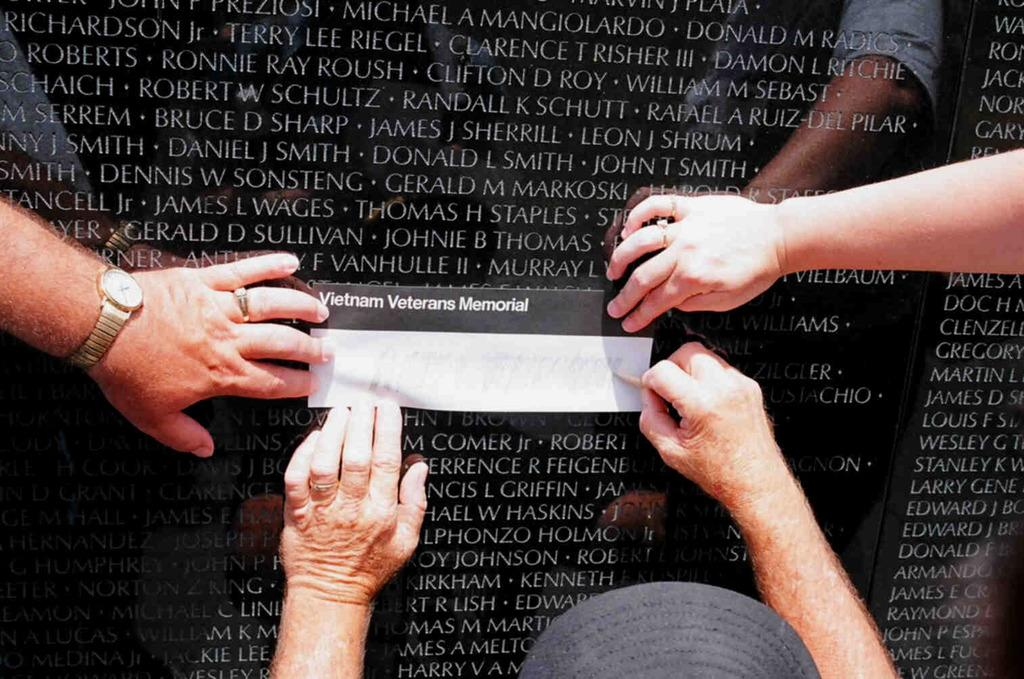What is located in the background of the image? There is a memorial in the background of the image. How many hands are depicted on the memorial? There are four hands present on the memorial. What is placed on the memorial? There is a paper on the memorial. What type of coast can be seen in the image? There is no coast present in the image; it features a memorial with four hands and a paper. 